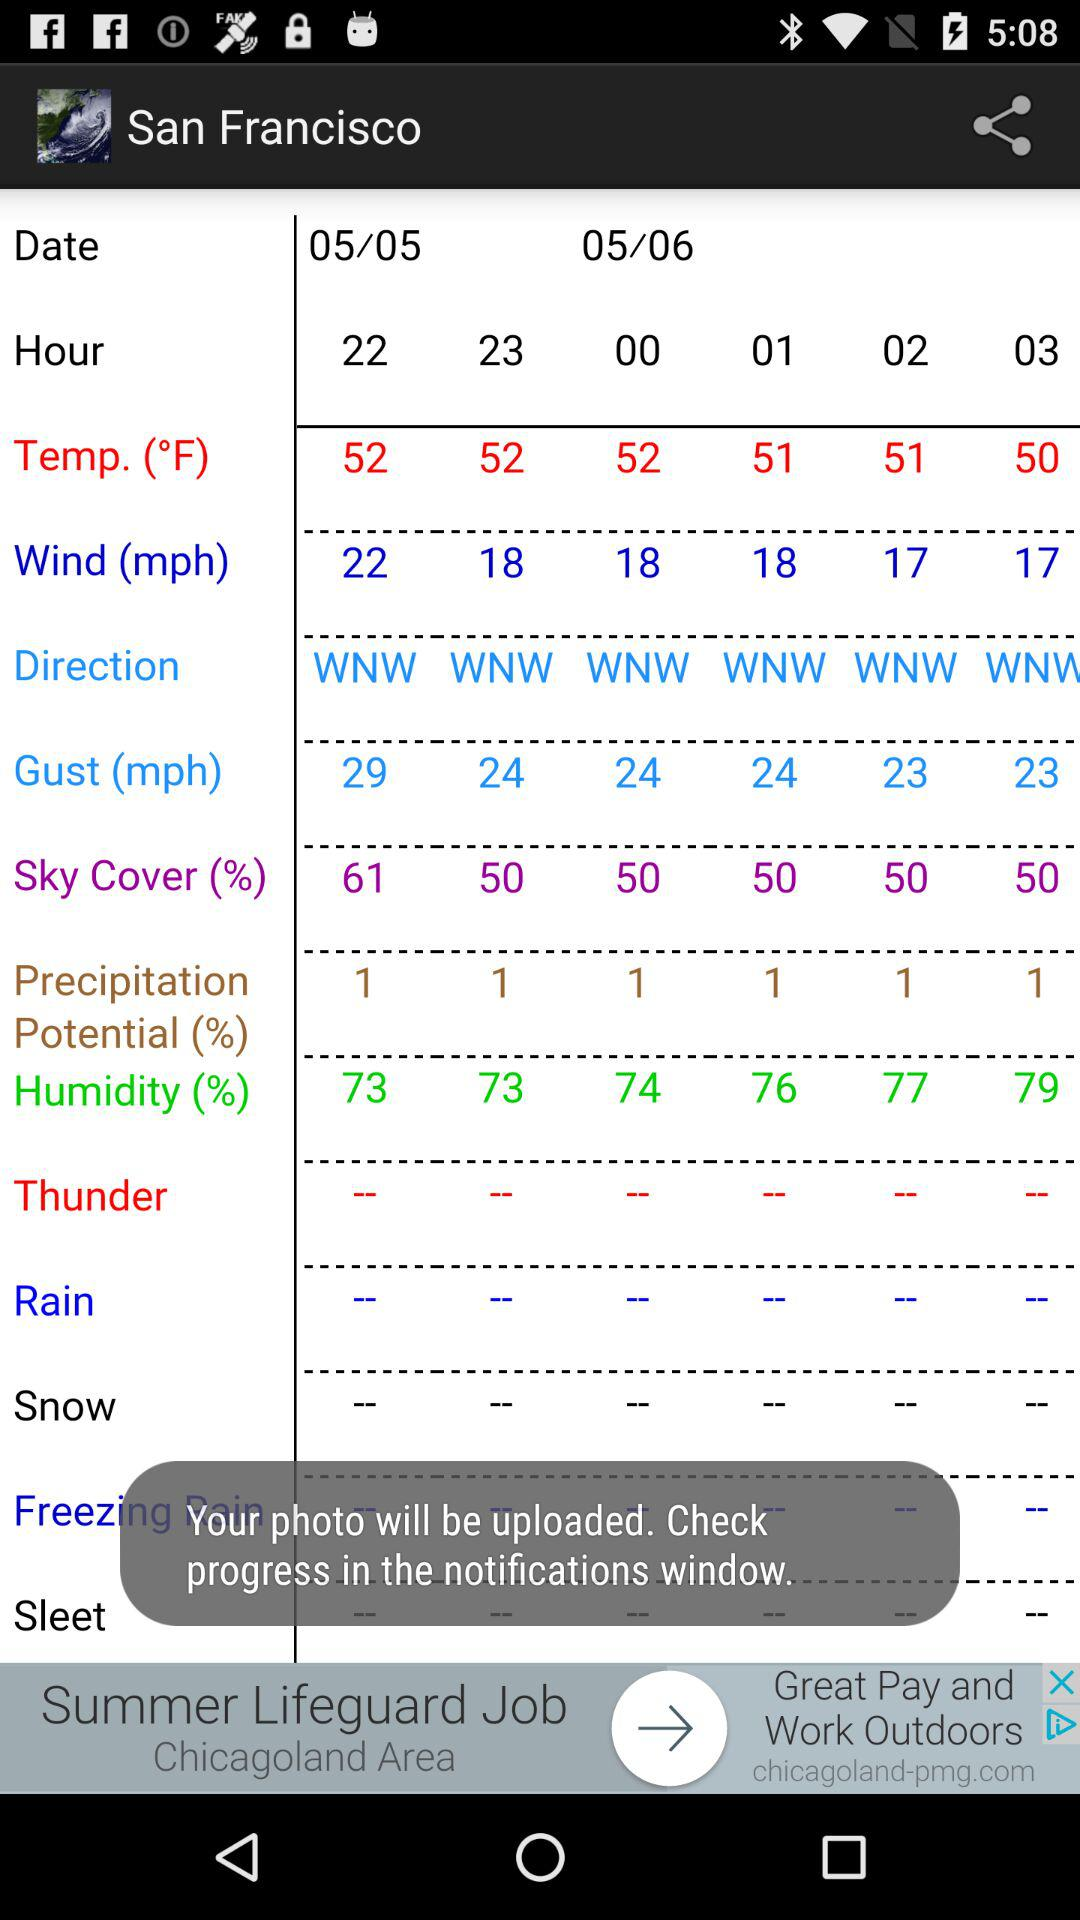What is the unit of wind speed? The unit of wind speed is mph. 